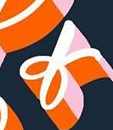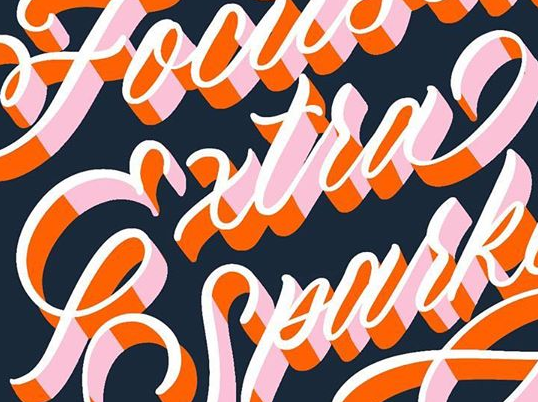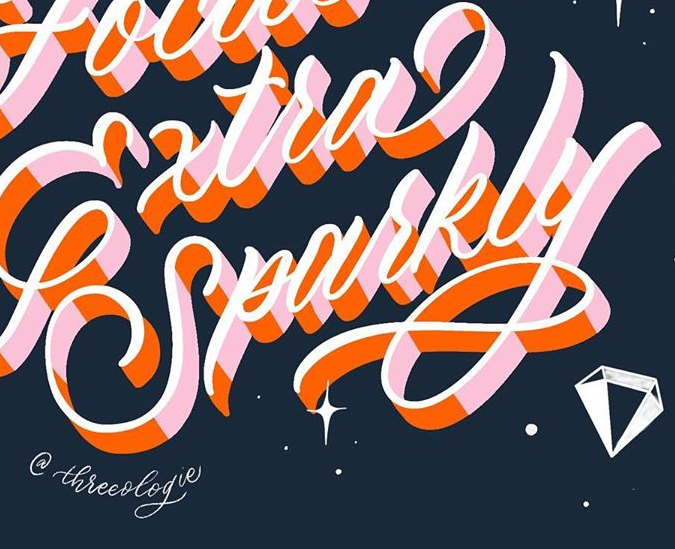What words can you see in these images in sequence, separated by a semicolon? of; Extra; Sparkly 